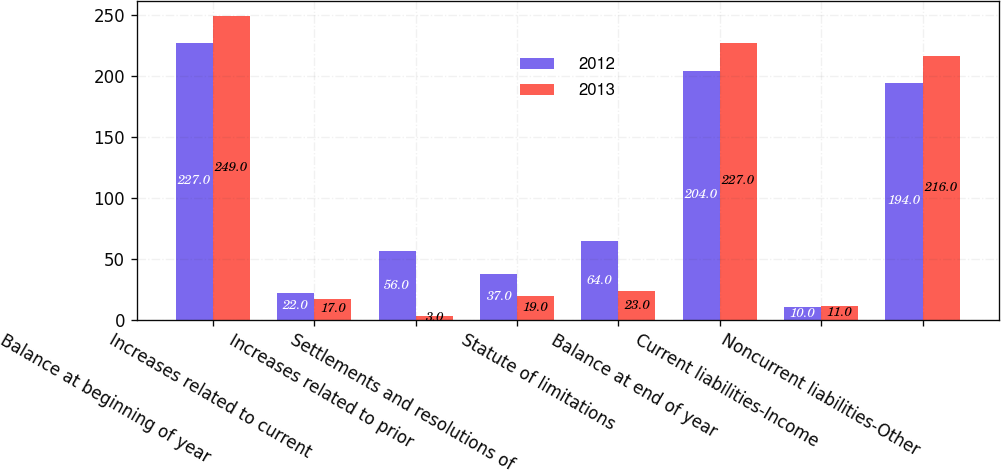<chart> <loc_0><loc_0><loc_500><loc_500><stacked_bar_chart><ecel><fcel>Balance at beginning of year<fcel>Increases related to current<fcel>Increases related to prior<fcel>Settlements and resolutions of<fcel>Statute of limitations<fcel>Balance at end of year<fcel>Current liabilities-Income<fcel>Noncurrent liabilities-Other<nl><fcel>2012<fcel>227<fcel>22<fcel>56<fcel>37<fcel>64<fcel>204<fcel>10<fcel>194<nl><fcel>2013<fcel>249<fcel>17<fcel>3<fcel>19<fcel>23<fcel>227<fcel>11<fcel>216<nl></chart> 